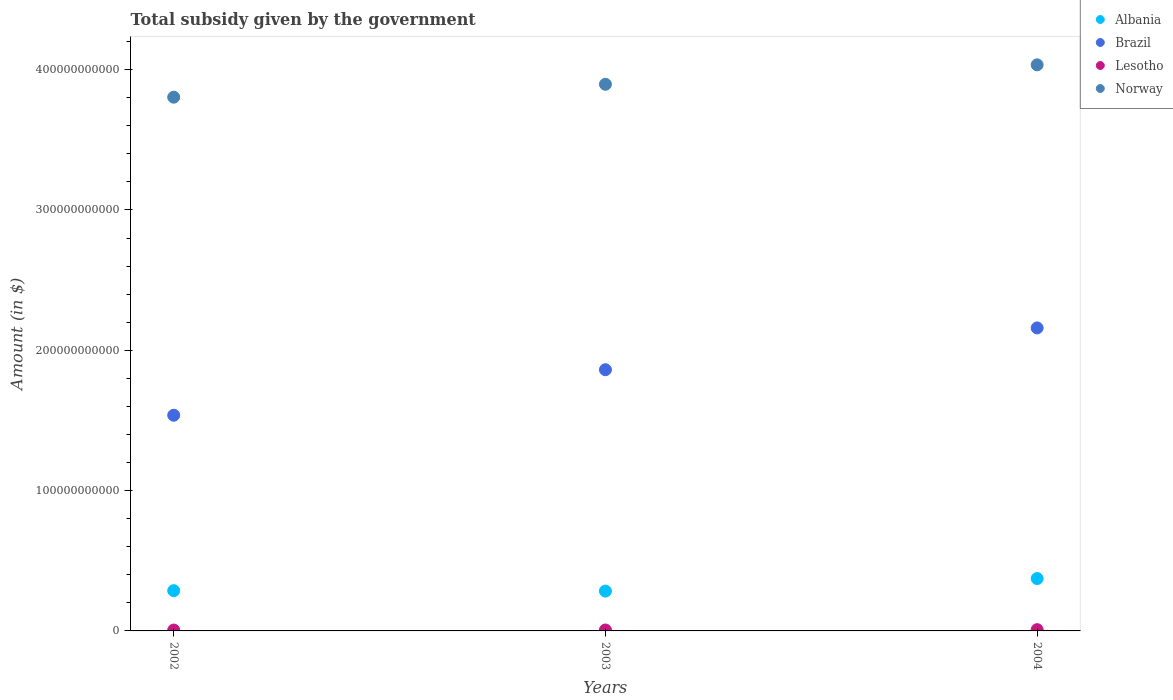How many different coloured dotlines are there?
Offer a very short reply. 4. What is the total revenue collected by the government in Albania in 2002?
Keep it short and to the point. 2.87e+1. Across all years, what is the maximum total revenue collected by the government in Lesotho?
Offer a very short reply. 8.99e+08. Across all years, what is the minimum total revenue collected by the government in Brazil?
Provide a succinct answer. 1.54e+11. In which year was the total revenue collected by the government in Albania maximum?
Provide a short and direct response. 2004. In which year was the total revenue collected by the government in Lesotho minimum?
Provide a succinct answer. 2002. What is the total total revenue collected by the government in Brazil in the graph?
Provide a succinct answer. 5.56e+11. What is the difference between the total revenue collected by the government in Albania in 2002 and that in 2004?
Make the answer very short. -8.66e+09. What is the difference between the total revenue collected by the government in Lesotho in 2002 and the total revenue collected by the government in Brazil in 2003?
Provide a succinct answer. -1.86e+11. What is the average total revenue collected by the government in Albania per year?
Offer a very short reply. 3.15e+1. In the year 2004, what is the difference between the total revenue collected by the government in Albania and total revenue collected by the government in Lesotho?
Provide a succinct answer. 3.64e+1. In how many years, is the total revenue collected by the government in Norway greater than 160000000000 $?
Give a very brief answer. 3. What is the ratio of the total revenue collected by the government in Albania in 2002 to that in 2003?
Give a very brief answer. 1.01. Is the difference between the total revenue collected by the government in Albania in 2003 and 2004 greater than the difference between the total revenue collected by the government in Lesotho in 2003 and 2004?
Offer a very short reply. No. What is the difference between the highest and the second highest total revenue collected by the government in Brazil?
Offer a terse response. 2.98e+1. What is the difference between the highest and the lowest total revenue collected by the government in Norway?
Your response must be concise. 2.31e+1. In how many years, is the total revenue collected by the government in Lesotho greater than the average total revenue collected by the government in Lesotho taken over all years?
Provide a short and direct response. 1. Is the sum of the total revenue collected by the government in Lesotho in 2003 and 2004 greater than the maximum total revenue collected by the government in Albania across all years?
Keep it short and to the point. No. Does the total revenue collected by the government in Lesotho monotonically increase over the years?
Offer a very short reply. Yes. Is the total revenue collected by the government in Norway strictly less than the total revenue collected by the government in Lesotho over the years?
Your answer should be very brief. No. How many years are there in the graph?
Offer a terse response. 3. What is the difference between two consecutive major ticks on the Y-axis?
Provide a short and direct response. 1.00e+11. Are the values on the major ticks of Y-axis written in scientific E-notation?
Provide a short and direct response. No. Does the graph contain any zero values?
Provide a short and direct response. No. How are the legend labels stacked?
Your answer should be compact. Vertical. What is the title of the graph?
Ensure brevity in your answer.  Total subsidy given by the government. What is the label or title of the Y-axis?
Provide a short and direct response. Amount (in $). What is the Amount (in $) in Albania in 2002?
Offer a terse response. 2.87e+1. What is the Amount (in $) in Brazil in 2002?
Provide a short and direct response. 1.54e+11. What is the Amount (in $) of Lesotho in 2002?
Provide a short and direct response. 6.15e+08. What is the Amount (in $) in Norway in 2002?
Make the answer very short. 3.80e+11. What is the Amount (in $) in Albania in 2003?
Provide a short and direct response. 2.84e+1. What is the Amount (in $) in Brazil in 2003?
Offer a terse response. 1.86e+11. What is the Amount (in $) of Lesotho in 2003?
Provide a short and direct response. 6.65e+08. What is the Amount (in $) in Norway in 2003?
Ensure brevity in your answer.  3.90e+11. What is the Amount (in $) of Albania in 2004?
Your answer should be very brief. 3.73e+1. What is the Amount (in $) of Brazil in 2004?
Your answer should be very brief. 2.16e+11. What is the Amount (in $) of Lesotho in 2004?
Ensure brevity in your answer.  8.99e+08. What is the Amount (in $) in Norway in 2004?
Give a very brief answer. 4.03e+11. Across all years, what is the maximum Amount (in $) of Albania?
Keep it short and to the point. 3.73e+1. Across all years, what is the maximum Amount (in $) in Brazil?
Provide a succinct answer. 2.16e+11. Across all years, what is the maximum Amount (in $) in Lesotho?
Offer a very short reply. 8.99e+08. Across all years, what is the maximum Amount (in $) of Norway?
Offer a terse response. 4.03e+11. Across all years, what is the minimum Amount (in $) in Albania?
Offer a terse response. 2.84e+1. Across all years, what is the minimum Amount (in $) of Brazil?
Your answer should be very brief. 1.54e+11. Across all years, what is the minimum Amount (in $) in Lesotho?
Your answer should be compact. 6.15e+08. Across all years, what is the minimum Amount (in $) of Norway?
Keep it short and to the point. 3.80e+11. What is the total Amount (in $) of Albania in the graph?
Give a very brief answer. 9.44e+1. What is the total Amount (in $) in Brazil in the graph?
Provide a short and direct response. 5.56e+11. What is the total Amount (in $) in Lesotho in the graph?
Give a very brief answer. 2.18e+09. What is the total Amount (in $) in Norway in the graph?
Provide a succinct answer. 1.17e+12. What is the difference between the Amount (in $) in Albania in 2002 and that in 2003?
Provide a short and direct response. 2.91e+08. What is the difference between the Amount (in $) in Brazil in 2002 and that in 2003?
Ensure brevity in your answer.  -3.24e+1. What is the difference between the Amount (in $) in Lesotho in 2002 and that in 2003?
Give a very brief answer. -4.99e+07. What is the difference between the Amount (in $) in Norway in 2002 and that in 2003?
Provide a succinct answer. -9.20e+09. What is the difference between the Amount (in $) in Albania in 2002 and that in 2004?
Your answer should be compact. -8.66e+09. What is the difference between the Amount (in $) in Brazil in 2002 and that in 2004?
Offer a very short reply. -6.22e+1. What is the difference between the Amount (in $) of Lesotho in 2002 and that in 2004?
Give a very brief answer. -2.84e+08. What is the difference between the Amount (in $) of Norway in 2002 and that in 2004?
Keep it short and to the point. -2.31e+1. What is the difference between the Amount (in $) in Albania in 2003 and that in 2004?
Make the answer very short. -8.95e+09. What is the difference between the Amount (in $) of Brazil in 2003 and that in 2004?
Offer a very short reply. -2.98e+1. What is the difference between the Amount (in $) of Lesotho in 2003 and that in 2004?
Your answer should be very brief. -2.35e+08. What is the difference between the Amount (in $) of Norway in 2003 and that in 2004?
Provide a succinct answer. -1.39e+1. What is the difference between the Amount (in $) in Albania in 2002 and the Amount (in $) in Brazil in 2003?
Provide a short and direct response. -1.57e+11. What is the difference between the Amount (in $) in Albania in 2002 and the Amount (in $) in Lesotho in 2003?
Your response must be concise. 2.80e+1. What is the difference between the Amount (in $) of Albania in 2002 and the Amount (in $) of Norway in 2003?
Offer a very short reply. -3.61e+11. What is the difference between the Amount (in $) in Brazil in 2002 and the Amount (in $) in Lesotho in 2003?
Keep it short and to the point. 1.53e+11. What is the difference between the Amount (in $) in Brazil in 2002 and the Amount (in $) in Norway in 2003?
Your answer should be very brief. -2.36e+11. What is the difference between the Amount (in $) in Lesotho in 2002 and the Amount (in $) in Norway in 2003?
Offer a terse response. -3.89e+11. What is the difference between the Amount (in $) of Albania in 2002 and the Amount (in $) of Brazil in 2004?
Offer a terse response. -1.87e+11. What is the difference between the Amount (in $) of Albania in 2002 and the Amount (in $) of Lesotho in 2004?
Offer a very short reply. 2.78e+1. What is the difference between the Amount (in $) in Albania in 2002 and the Amount (in $) in Norway in 2004?
Offer a terse response. -3.75e+11. What is the difference between the Amount (in $) in Brazil in 2002 and the Amount (in $) in Lesotho in 2004?
Keep it short and to the point. 1.53e+11. What is the difference between the Amount (in $) of Brazil in 2002 and the Amount (in $) of Norway in 2004?
Offer a terse response. -2.50e+11. What is the difference between the Amount (in $) of Lesotho in 2002 and the Amount (in $) of Norway in 2004?
Your answer should be very brief. -4.03e+11. What is the difference between the Amount (in $) in Albania in 2003 and the Amount (in $) in Brazil in 2004?
Provide a short and direct response. -1.88e+11. What is the difference between the Amount (in $) of Albania in 2003 and the Amount (in $) of Lesotho in 2004?
Offer a very short reply. 2.75e+1. What is the difference between the Amount (in $) of Albania in 2003 and the Amount (in $) of Norway in 2004?
Provide a short and direct response. -3.75e+11. What is the difference between the Amount (in $) of Brazil in 2003 and the Amount (in $) of Lesotho in 2004?
Make the answer very short. 1.85e+11. What is the difference between the Amount (in $) in Brazil in 2003 and the Amount (in $) in Norway in 2004?
Your answer should be very brief. -2.17e+11. What is the difference between the Amount (in $) of Lesotho in 2003 and the Amount (in $) of Norway in 2004?
Give a very brief answer. -4.03e+11. What is the average Amount (in $) of Albania per year?
Make the answer very short. 3.15e+1. What is the average Amount (in $) in Brazil per year?
Ensure brevity in your answer.  1.85e+11. What is the average Amount (in $) of Lesotho per year?
Your response must be concise. 7.26e+08. What is the average Amount (in $) of Norway per year?
Your response must be concise. 3.91e+11. In the year 2002, what is the difference between the Amount (in $) of Albania and Amount (in $) of Brazil?
Your answer should be very brief. -1.25e+11. In the year 2002, what is the difference between the Amount (in $) of Albania and Amount (in $) of Lesotho?
Provide a short and direct response. 2.81e+1. In the year 2002, what is the difference between the Amount (in $) of Albania and Amount (in $) of Norway?
Offer a very short reply. -3.52e+11. In the year 2002, what is the difference between the Amount (in $) of Brazil and Amount (in $) of Lesotho?
Your answer should be compact. 1.53e+11. In the year 2002, what is the difference between the Amount (in $) in Brazil and Amount (in $) in Norway?
Ensure brevity in your answer.  -2.27e+11. In the year 2002, what is the difference between the Amount (in $) in Lesotho and Amount (in $) in Norway?
Your answer should be compact. -3.80e+11. In the year 2003, what is the difference between the Amount (in $) in Albania and Amount (in $) in Brazil?
Give a very brief answer. -1.58e+11. In the year 2003, what is the difference between the Amount (in $) in Albania and Amount (in $) in Lesotho?
Your answer should be compact. 2.77e+1. In the year 2003, what is the difference between the Amount (in $) of Albania and Amount (in $) of Norway?
Keep it short and to the point. -3.61e+11. In the year 2003, what is the difference between the Amount (in $) in Brazil and Amount (in $) in Lesotho?
Your answer should be compact. 1.85e+11. In the year 2003, what is the difference between the Amount (in $) in Brazil and Amount (in $) in Norway?
Offer a terse response. -2.03e+11. In the year 2003, what is the difference between the Amount (in $) in Lesotho and Amount (in $) in Norway?
Give a very brief answer. -3.89e+11. In the year 2004, what is the difference between the Amount (in $) in Albania and Amount (in $) in Brazil?
Give a very brief answer. -1.79e+11. In the year 2004, what is the difference between the Amount (in $) in Albania and Amount (in $) in Lesotho?
Provide a short and direct response. 3.64e+1. In the year 2004, what is the difference between the Amount (in $) of Albania and Amount (in $) of Norway?
Your answer should be very brief. -3.66e+11. In the year 2004, what is the difference between the Amount (in $) of Brazil and Amount (in $) of Lesotho?
Offer a very short reply. 2.15e+11. In the year 2004, what is the difference between the Amount (in $) of Brazil and Amount (in $) of Norway?
Keep it short and to the point. -1.87e+11. In the year 2004, what is the difference between the Amount (in $) in Lesotho and Amount (in $) in Norway?
Keep it short and to the point. -4.03e+11. What is the ratio of the Amount (in $) in Albania in 2002 to that in 2003?
Provide a short and direct response. 1.01. What is the ratio of the Amount (in $) in Brazil in 2002 to that in 2003?
Ensure brevity in your answer.  0.83. What is the ratio of the Amount (in $) in Lesotho in 2002 to that in 2003?
Your answer should be very brief. 0.92. What is the ratio of the Amount (in $) of Norway in 2002 to that in 2003?
Make the answer very short. 0.98. What is the ratio of the Amount (in $) of Albania in 2002 to that in 2004?
Give a very brief answer. 0.77. What is the ratio of the Amount (in $) in Brazil in 2002 to that in 2004?
Provide a succinct answer. 0.71. What is the ratio of the Amount (in $) in Lesotho in 2002 to that in 2004?
Give a very brief answer. 0.68. What is the ratio of the Amount (in $) in Norway in 2002 to that in 2004?
Your answer should be very brief. 0.94. What is the ratio of the Amount (in $) of Albania in 2003 to that in 2004?
Provide a short and direct response. 0.76. What is the ratio of the Amount (in $) in Brazil in 2003 to that in 2004?
Offer a very short reply. 0.86. What is the ratio of the Amount (in $) of Lesotho in 2003 to that in 2004?
Ensure brevity in your answer.  0.74. What is the ratio of the Amount (in $) of Norway in 2003 to that in 2004?
Ensure brevity in your answer.  0.97. What is the difference between the highest and the second highest Amount (in $) of Albania?
Offer a very short reply. 8.66e+09. What is the difference between the highest and the second highest Amount (in $) of Brazil?
Keep it short and to the point. 2.98e+1. What is the difference between the highest and the second highest Amount (in $) in Lesotho?
Your response must be concise. 2.35e+08. What is the difference between the highest and the second highest Amount (in $) in Norway?
Your answer should be compact. 1.39e+1. What is the difference between the highest and the lowest Amount (in $) in Albania?
Your response must be concise. 8.95e+09. What is the difference between the highest and the lowest Amount (in $) in Brazil?
Offer a terse response. 6.22e+1. What is the difference between the highest and the lowest Amount (in $) of Lesotho?
Give a very brief answer. 2.84e+08. What is the difference between the highest and the lowest Amount (in $) of Norway?
Provide a succinct answer. 2.31e+1. 